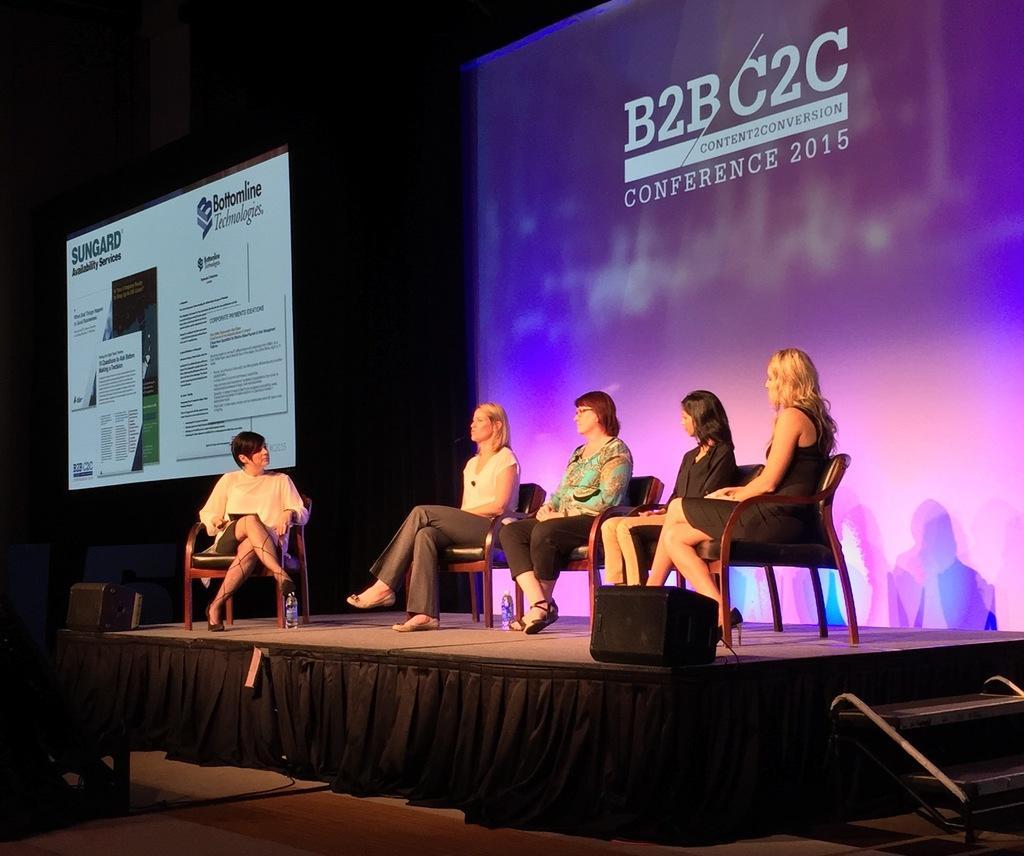Describe this image in one or two sentences. In this image we can see a few people sitting on the chairs, there are bottles and some other objects on the stage, also we can see the screens with some text and the background is dark. 